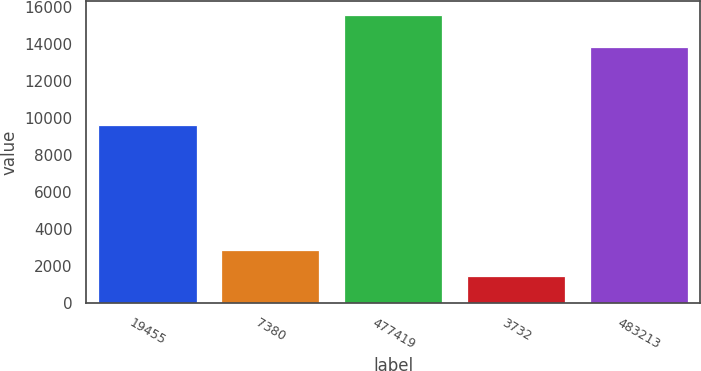Convert chart to OTSL. <chart><loc_0><loc_0><loc_500><loc_500><bar_chart><fcel>19455<fcel>7380<fcel>477419<fcel>3732<fcel>483213<nl><fcel>9623<fcel>2878.7<fcel>15539<fcel>1472<fcel>13844<nl></chart> 